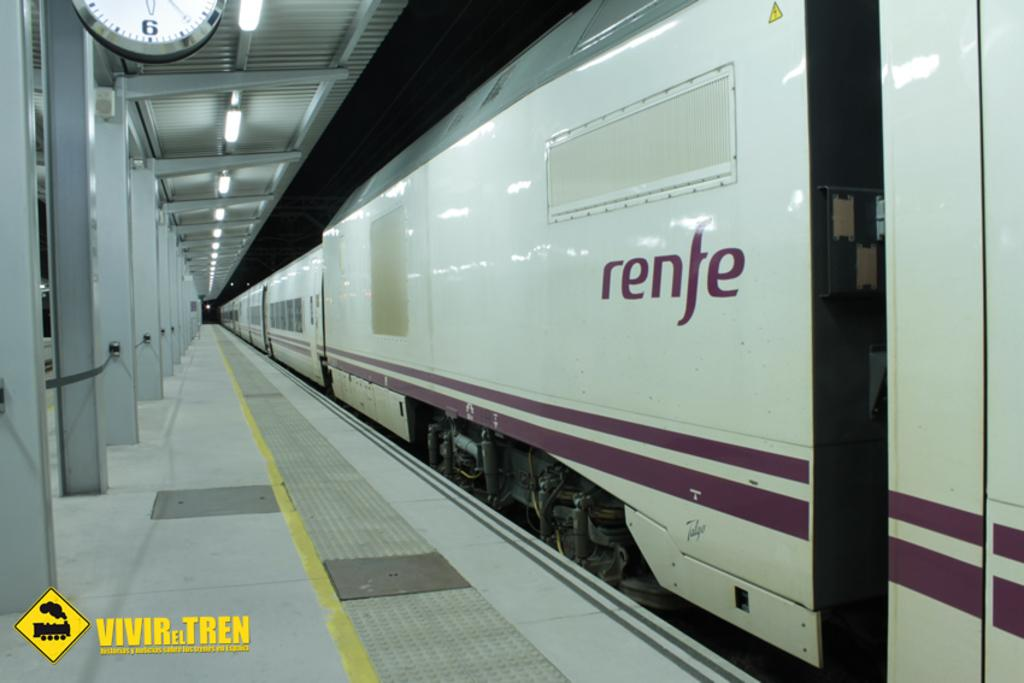<image>
Render a clear and concise summary of the photo. A renfe, underground train is stopped at a boarding area that is completely free of people. 